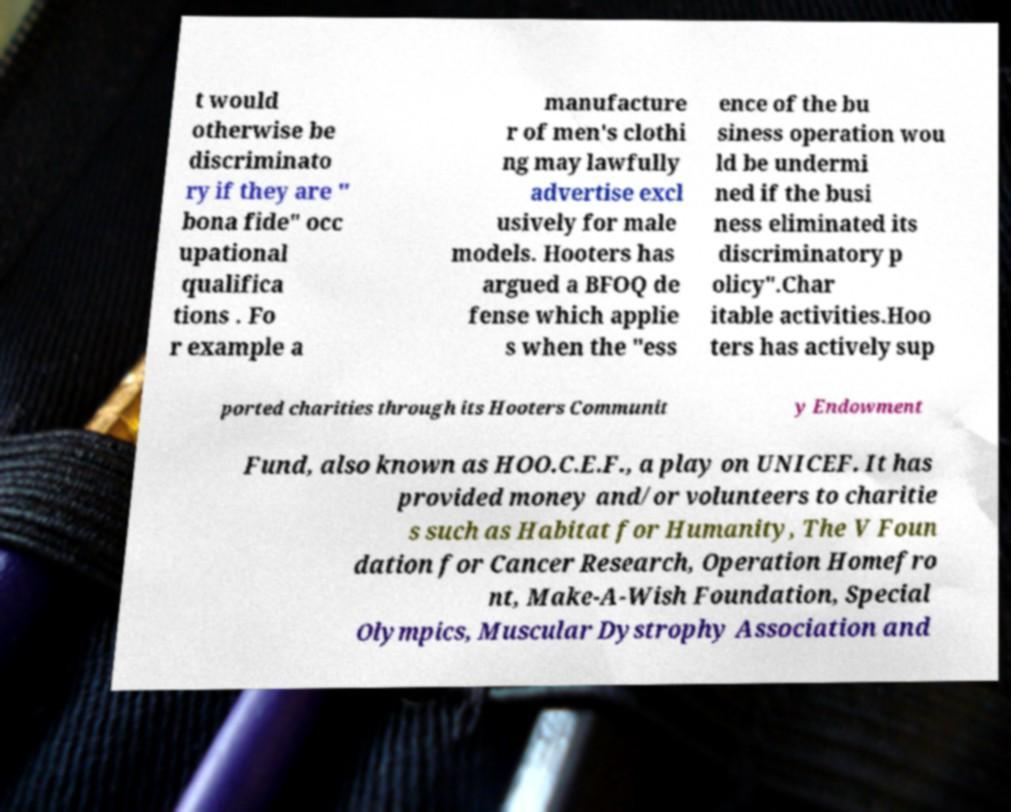I need the written content from this picture converted into text. Can you do that? t would otherwise be discriminato ry if they are " bona fide" occ upational qualifica tions . Fo r example a manufacture r of men's clothi ng may lawfully advertise excl usively for male models. Hooters has argued a BFOQ de fense which applie s when the "ess ence of the bu siness operation wou ld be undermi ned if the busi ness eliminated its discriminatory p olicy".Char itable activities.Hoo ters has actively sup ported charities through its Hooters Communit y Endowment Fund, also known as HOO.C.E.F., a play on UNICEF. It has provided money and/or volunteers to charitie s such as Habitat for Humanity, The V Foun dation for Cancer Research, Operation Homefro nt, Make-A-Wish Foundation, Special Olympics, Muscular Dystrophy Association and 